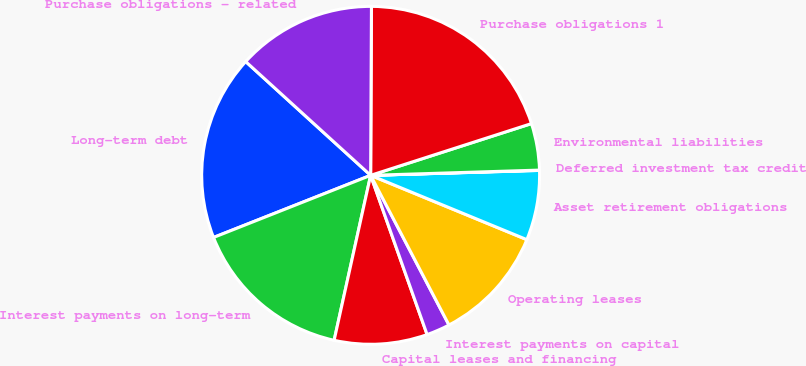Convert chart to OTSL. <chart><loc_0><loc_0><loc_500><loc_500><pie_chart><fcel>Long-term debt<fcel>Interest payments on long-term<fcel>Capital leases and financing<fcel>Interest payments on capital<fcel>Operating leases<fcel>Asset retirement obligations<fcel>Deferred investment tax credit<fcel>Environmental liabilities<fcel>Purchase obligations 1<fcel>Purchase obligations - related<nl><fcel>17.75%<fcel>15.54%<fcel>8.89%<fcel>2.25%<fcel>11.11%<fcel>6.68%<fcel>0.03%<fcel>4.46%<fcel>19.97%<fcel>13.32%<nl></chart> 